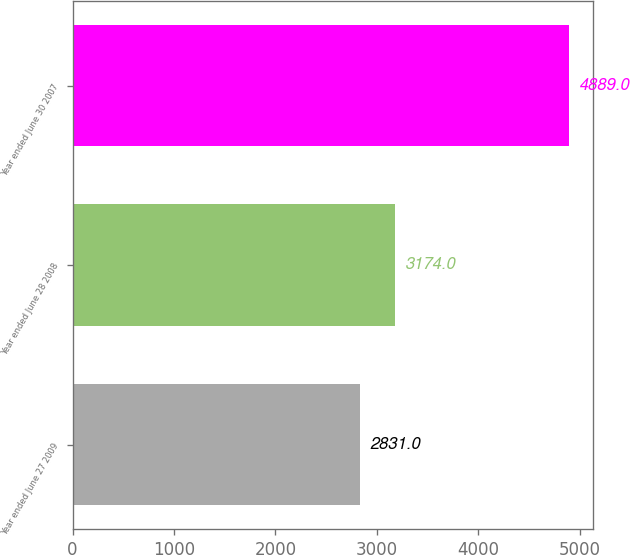<chart> <loc_0><loc_0><loc_500><loc_500><bar_chart><fcel>Year ended June 27 2009<fcel>Year ended June 28 2008<fcel>Year ended June 30 2007<nl><fcel>2831<fcel>3174<fcel>4889<nl></chart> 